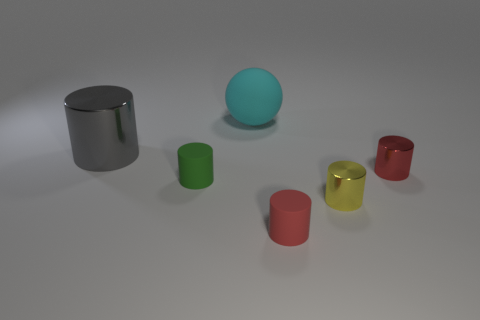What is the color of the big shiny object?
Provide a succinct answer. Gray. There is a big thing that is behind the big gray cylinder; is there a gray object that is in front of it?
Your answer should be compact. Yes. How many green rubber objects have the same size as the gray cylinder?
Offer a very short reply. 0. How many cyan matte objects are on the right side of the small rubber object that is to the left of the rubber object in front of the tiny green cylinder?
Your answer should be very brief. 1. How many things are both to the right of the small green rubber cylinder and behind the red metal cylinder?
Keep it short and to the point. 1. How many matte things are either large objects or green cylinders?
Your answer should be compact. 2. What is the material of the tiny red thing behind the red thing in front of the tiny red cylinder behind the green rubber object?
Make the answer very short. Metal. What material is the red cylinder that is on the right side of the object in front of the yellow shiny cylinder made of?
Make the answer very short. Metal. Does the shiny object in front of the red metallic cylinder have the same size as the cyan rubber object behind the red matte cylinder?
Ensure brevity in your answer.  No. How many small things are either gray shiny blocks or matte things?
Ensure brevity in your answer.  2. 